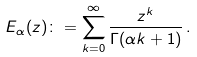Convert formula to latex. <formula><loc_0><loc_0><loc_500><loc_500>E _ { \alpha } ( z ) \colon = \sum _ { k = 0 } ^ { \infty } \frac { z ^ { k } } { \Gamma ( \alpha k + 1 ) } \, .</formula> 